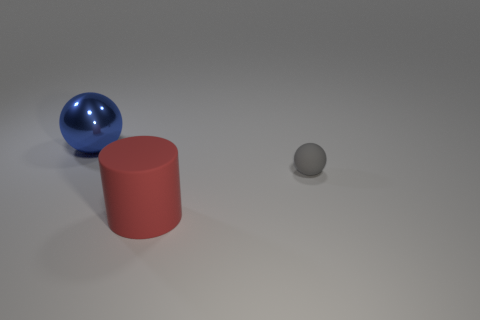Add 2 large things. How many objects exist? 5 Subtract 1 cylinders. How many cylinders are left? 0 Subtract all gray spheres. How many spheres are left? 1 Subtract all spheres. How many objects are left? 1 Add 3 gray things. How many gray things are left? 4 Add 3 brown cubes. How many brown cubes exist? 3 Subtract 0 green spheres. How many objects are left? 3 Subtract all cyan cylinders. Subtract all green balls. How many cylinders are left? 1 Subtract all small gray matte objects. Subtract all gray rubber spheres. How many objects are left? 1 